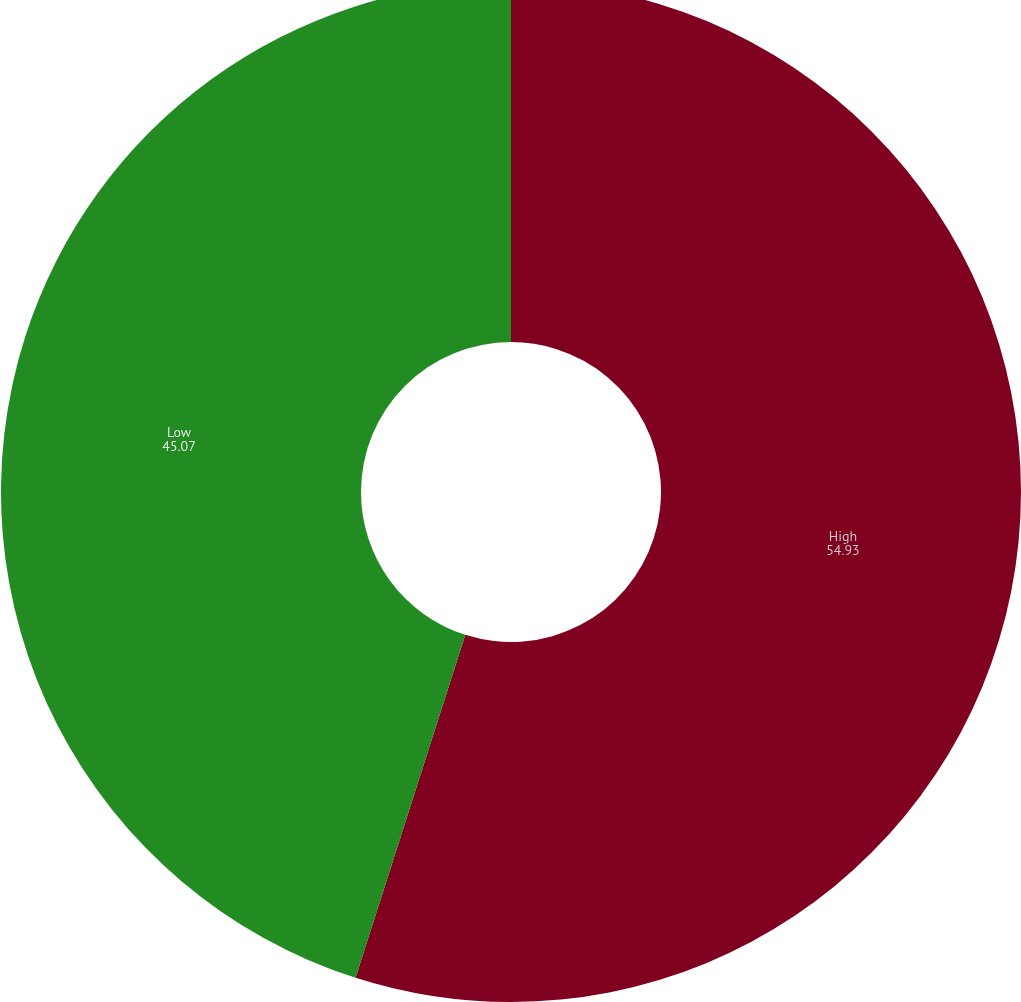Convert chart. <chart><loc_0><loc_0><loc_500><loc_500><pie_chart><fcel>High<fcel>Low<nl><fcel>54.93%<fcel>45.07%<nl></chart> 